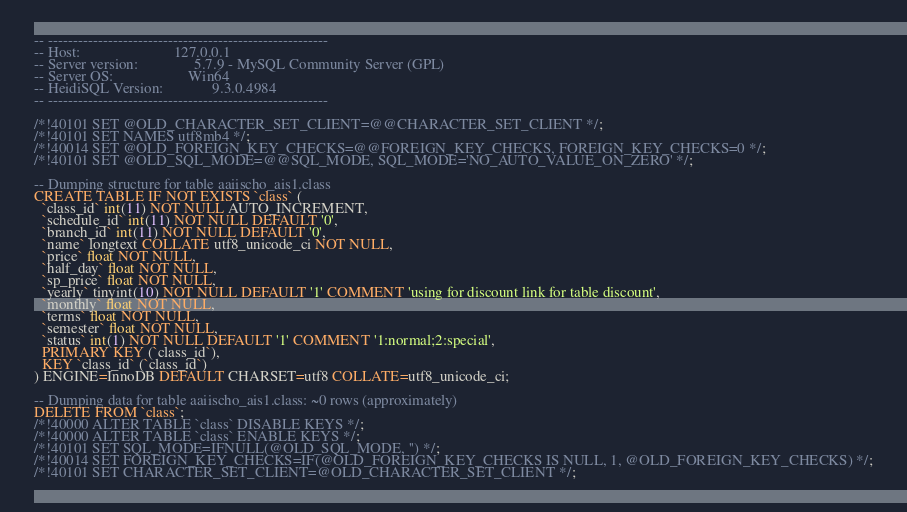<code> <loc_0><loc_0><loc_500><loc_500><_SQL_>-- --------------------------------------------------------
-- Host:                         127.0.0.1
-- Server version:               5.7.9 - MySQL Community Server (GPL)
-- Server OS:                    Win64
-- HeidiSQL Version:             9.3.0.4984
-- --------------------------------------------------------

/*!40101 SET @OLD_CHARACTER_SET_CLIENT=@@CHARACTER_SET_CLIENT */;
/*!40101 SET NAMES utf8mb4 */;
/*!40014 SET @OLD_FOREIGN_KEY_CHECKS=@@FOREIGN_KEY_CHECKS, FOREIGN_KEY_CHECKS=0 */;
/*!40101 SET @OLD_SQL_MODE=@@SQL_MODE, SQL_MODE='NO_AUTO_VALUE_ON_ZERO' */;

-- Dumping structure for table aaiischo_ais1.class
CREATE TABLE IF NOT EXISTS `class` (
  `class_id` int(11) NOT NULL AUTO_INCREMENT,
  `schedule_id` int(11) NOT NULL DEFAULT '0',
  `branch_id` int(11) NOT NULL DEFAULT '0',
  `name` longtext COLLATE utf8_unicode_ci NOT NULL,
  `price` float NOT NULL,
  `half_day` float NOT NULL,
  `sp_price` float NOT NULL,
  `yearly` tinyint(10) NOT NULL DEFAULT '1' COMMENT 'using for discount link for table discount',
  `monthly` float NOT NULL,
  `terms` float NOT NULL,
  `semester` float NOT NULL,
  `status` int(1) NOT NULL DEFAULT '1' COMMENT '1:normal;2:special',
  PRIMARY KEY (`class_id`),
  KEY `class_id` (`class_id`)
) ENGINE=InnoDB DEFAULT CHARSET=utf8 COLLATE=utf8_unicode_ci;

-- Dumping data for table aaiischo_ais1.class: ~0 rows (approximately)
DELETE FROM `class`;
/*!40000 ALTER TABLE `class` DISABLE KEYS */;
/*!40000 ALTER TABLE `class` ENABLE KEYS */;
/*!40101 SET SQL_MODE=IFNULL(@OLD_SQL_MODE, '') */;
/*!40014 SET FOREIGN_KEY_CHECKS=IF(@OLD_FOREIGN_KEY_CHECKS IS NULL, 1, @OLD_FOREIGN_KEY_CHECKS) */;
/*!40101 SET CHARACTER_SET_CLIENT=@OLD_CHARACTER_SET_CLIENT */;
</code> 